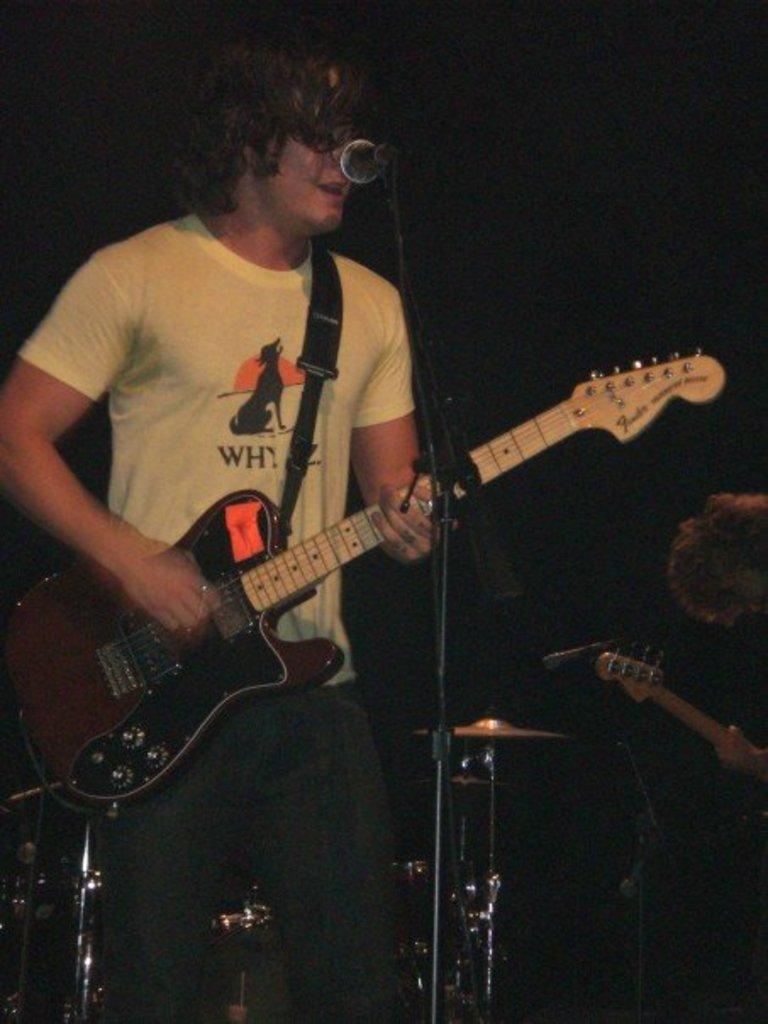How would you summarize this image in a sentence or two? In this image i can see a man is playing a guitar in front of a microphone. 